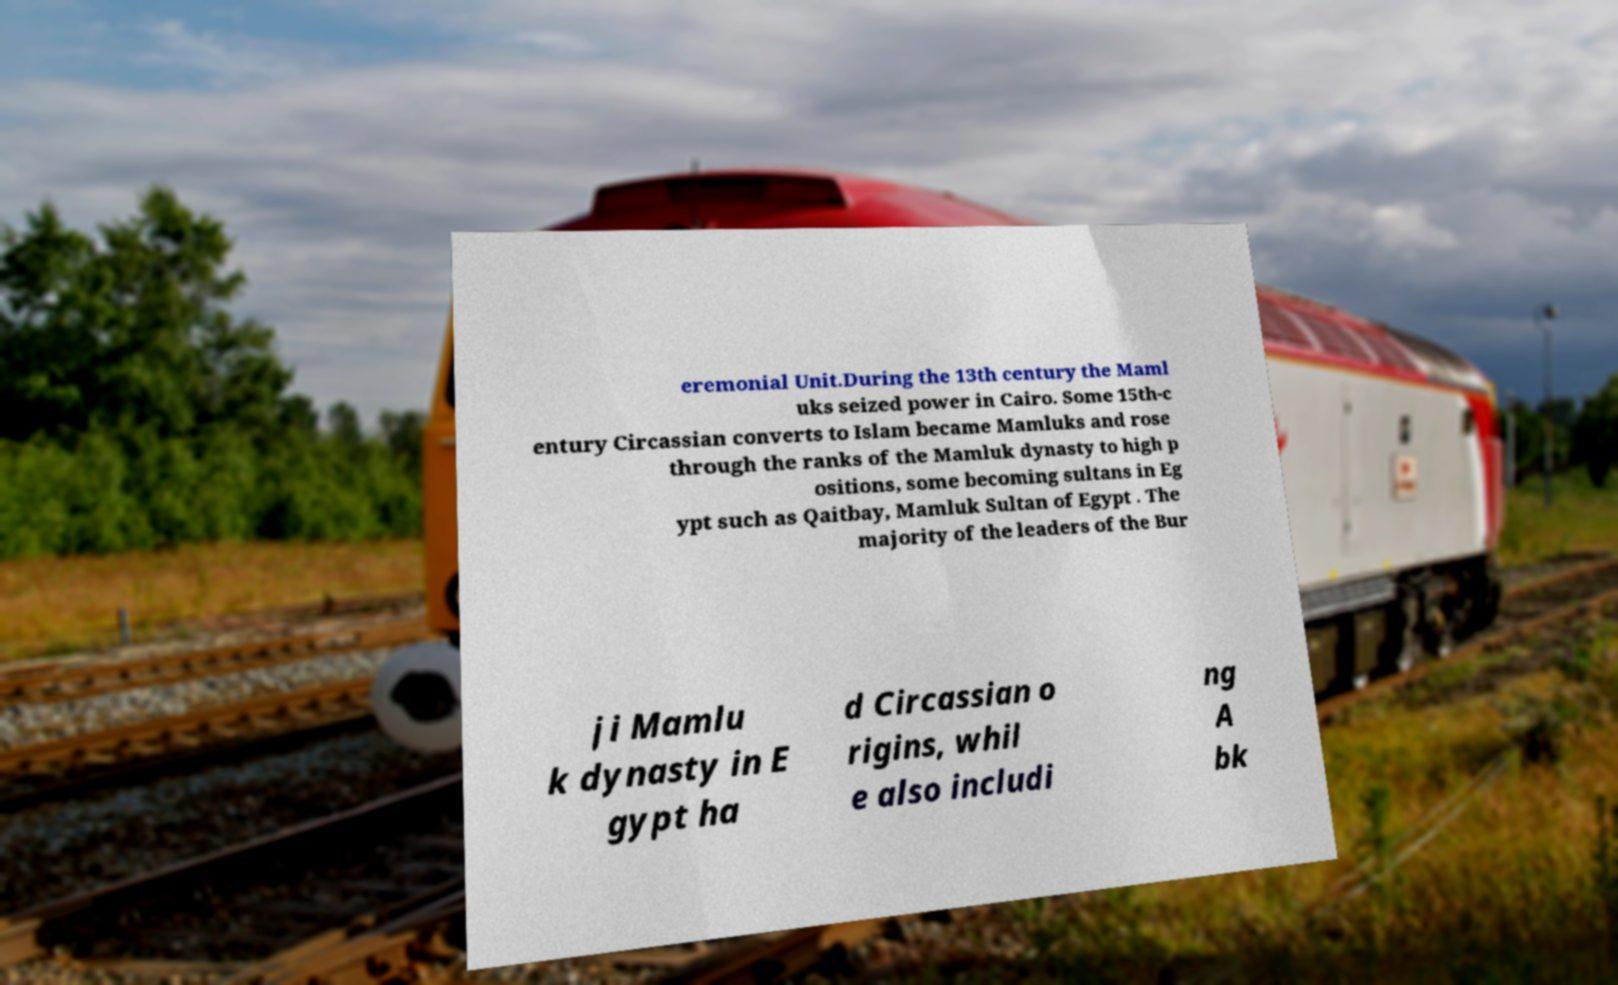I need the written content from this picture converted into text. Can you do that? eremonial Unit.During the 13th century the Maml uks seized power in Cairo. Some 15th-c entury Circassian converts to Islam became Mamluks and rose through the ranks of the Mamluk dynasty to high p ositions, some becoming sultans in Eg ypt such as Qaitbay, Mamluk Sultan of Egypt . The majority of the leaders of the Bur ji Mamlu k dynasty in E gypt ha d Circassian o rigins, whil e also includi ng A bk 